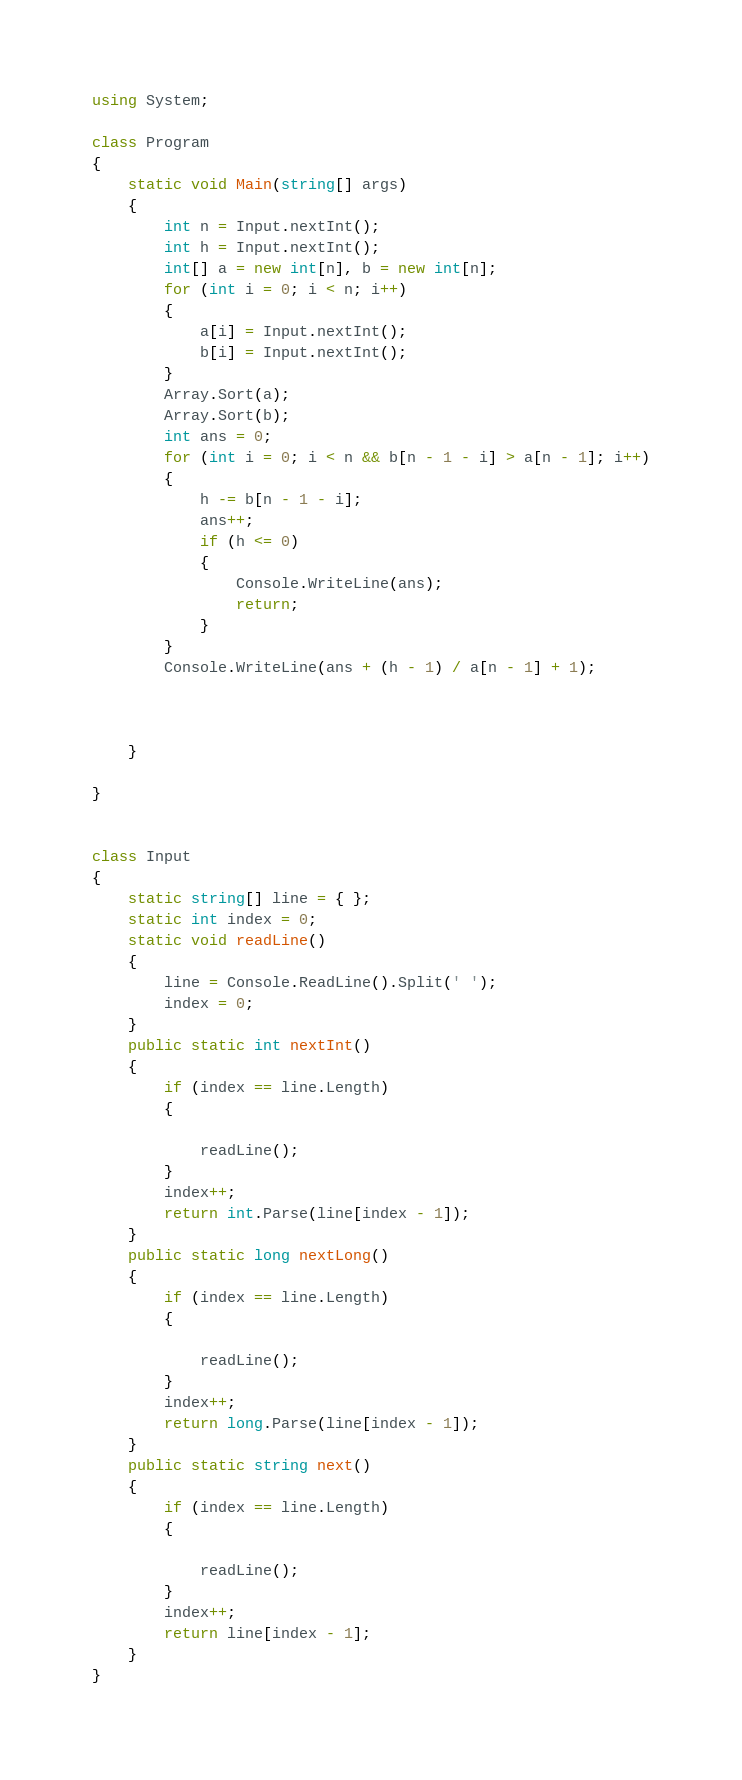Convert code to text. <code><loc_0><loc_0><loc_500><loc_500><_C#_>using System;

class Program
{
    static void Main(string[] args)
    {
        int n = Input.nextInt();
        int h = Input.nextInt();
        int[] a = new int[n], b = new int[n];
        for (int i = 0; i < n; i++)
        {
            a[i] = Input.nextInt();
            b[i] = Input.nextInt();
        }
        Array.Sort(a);
        Array.Sort(b);
        int ans = 0;
        for (int i = 0; i < n && b[n - 1 - i] > a[n - 1]; i++)
        {
            h -= b[n - 1 - i];
            ans++;
            if (h <= 0)
            {
                Console.WriteLine(ans);
                return;
            }
        }
        Console.WriteLine(ans + (h - 1) / a[n - 1] + 1);



    }

}


class Input
{
    static string[] line = { };
    static int index = 0;
    static void readLine()
    {
        line = Console.ReadLine().Split(' ');
        index = 0;
    }
    public static int nextInt()
    {
        if (index == line.Length)
        {

            readLine();
        }
        index++;
        return int.Parse(line[index - 1]);
    }
    public static long nextLong()
    {
        if (index == line.Length)
        {

            readLine();
        }
        index++;
        return long.Parse(line[index - 1]);
    }
    public static string next()
    {
        if (index == line.Length)
        {

            readLine();
        }
        index++;
        return line[index - 1];
    }
}


</code> 